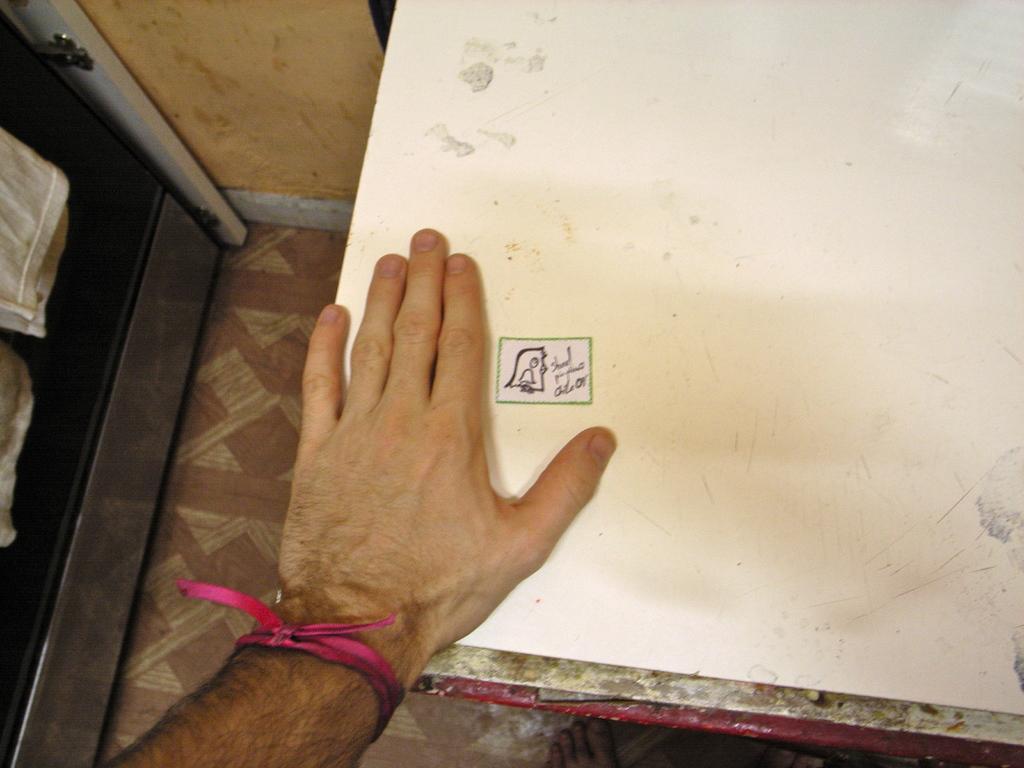Could you give a brief overview of what you see in this image? In this picture we can observe a white color table on which there is a human hand. We can observe a pink color ribbon tied to this hand. There is yellow color wall. On the left side we can observe a white color cloth. 